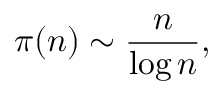Convert formula to latex. <formula><loc_0><loc_0><loc_500><loc_500>\pi ( n ) \sim { \frac { n } { \log n } } ,</formula> 